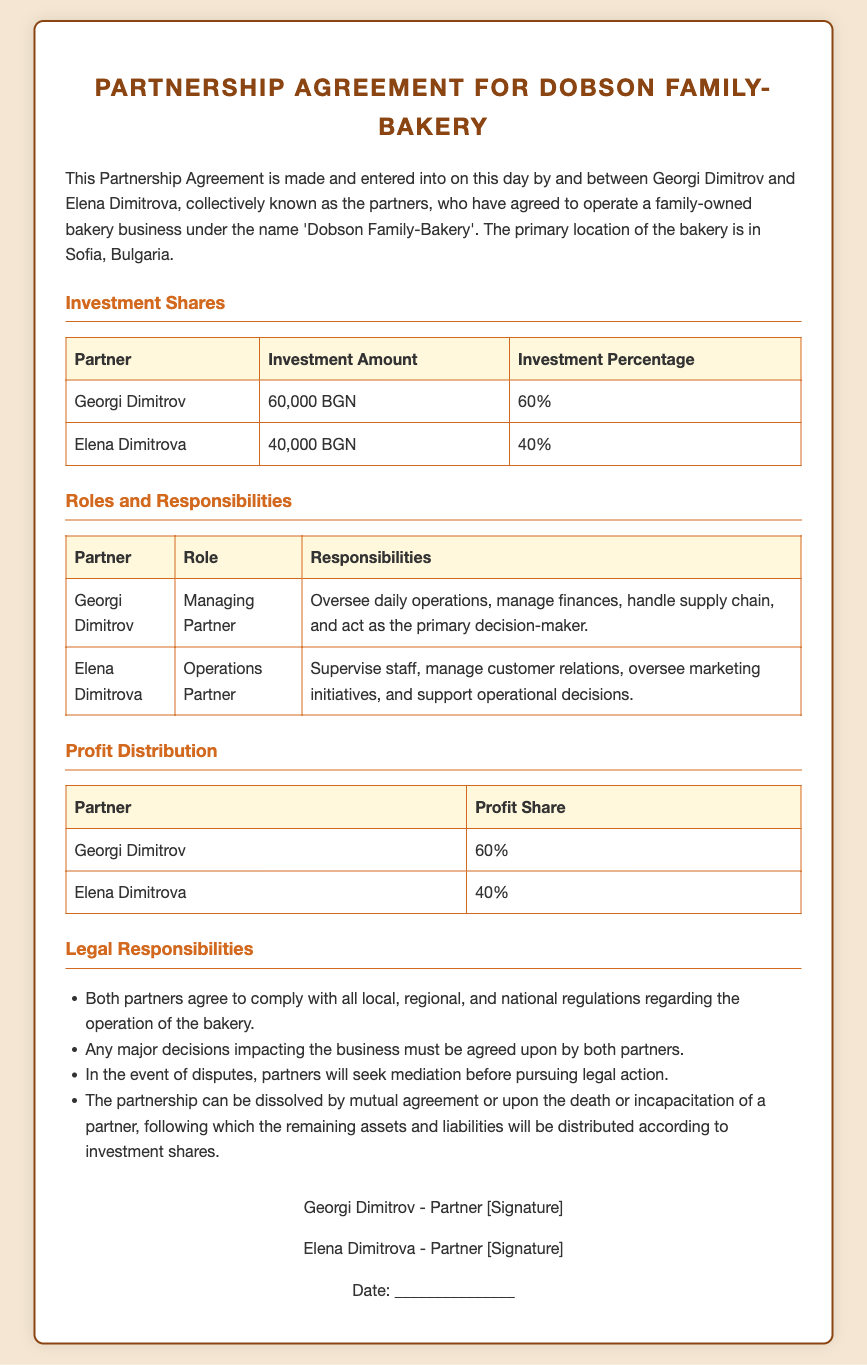What is the name of the business? The document states that the family-owned business is called 'Dobson Family-Bakery'.
Answer: Dobson Family-Bakery Who is the managing partner? According to the document, Georgi Dimitrov holds the position of Managing Partner.
Answer: Georgi Dimitrov What is Elena Dimitrova's investment amount? The partnership agreement indicates that Elena Dimitrova invested 40,000 BGN.
Answer: 40,000 BGN What is the profit share for Georgi Dimitrov? The document specifies that Georgi Dimitrov has a profit share of 60%.
Answer: 60% What happens in the event of a dispute? The agreement mentions that partners will seek mediation before pursuing legal action in case of any disputes.
Answer: Mediation What is the total investment by both partners? The total investment can be calculated by adding Georgi's and Elena's contributions, which is 60,000 BGN + 40,000 BGN.
Answer: 100,000 BGN What percentage of profit does Elena receive? The profit distribution table states that Elena Dimitrova receives 40% of the profits.
Answer: 40% What are the legal responsibilities of the partners? The document lists several responsibilities, including compliance with regulations and decision agreement, indicating shared legal obligations.
Answer: Compliance with regulations When was the agreement made? The document refers to the date as "this day," meaning it was signed on the day of its creation.
Answer: This day 